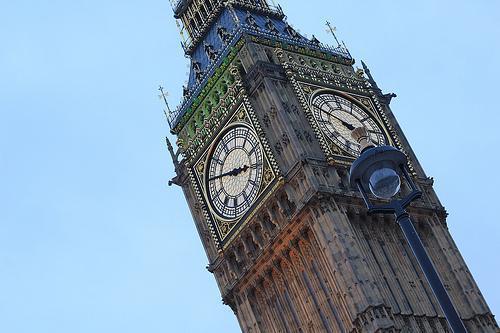How many clock towers are in this picture?
Give a very brief answer. 1. 